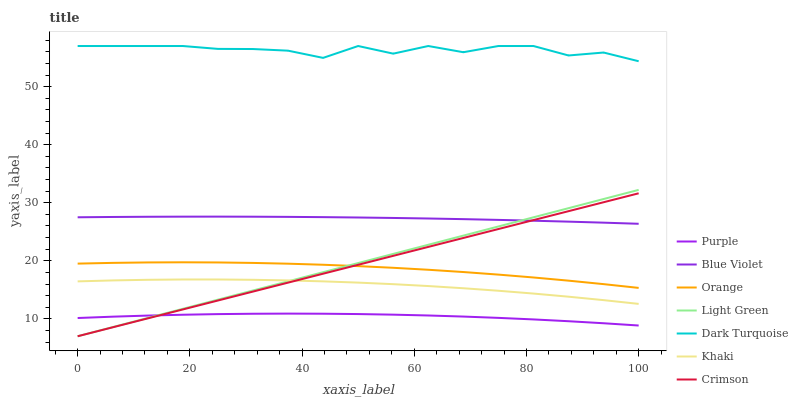Does Dark Turquoise have the minimum area under the curve?
Answer yes or no. No. Does Purple have the maximum area under the curve?
Answer yes or no. No. Is Purple the smoothest?
Answer yes or no. No. Is Purple the roughest?
Answer yes or no. No. Does Purple have the lowest value?
Answer yes or no. No. Does Purple have the highest value?
Answer yes or no. No. Is Crimson less than Dark Turquoise?
Answer yes or no. Yes. Is Dark Turquoise greater than Orange?
Answer yes or no. Yes. Does Crimson intersect Dark Turquoise?
Answer yes or no. No. 